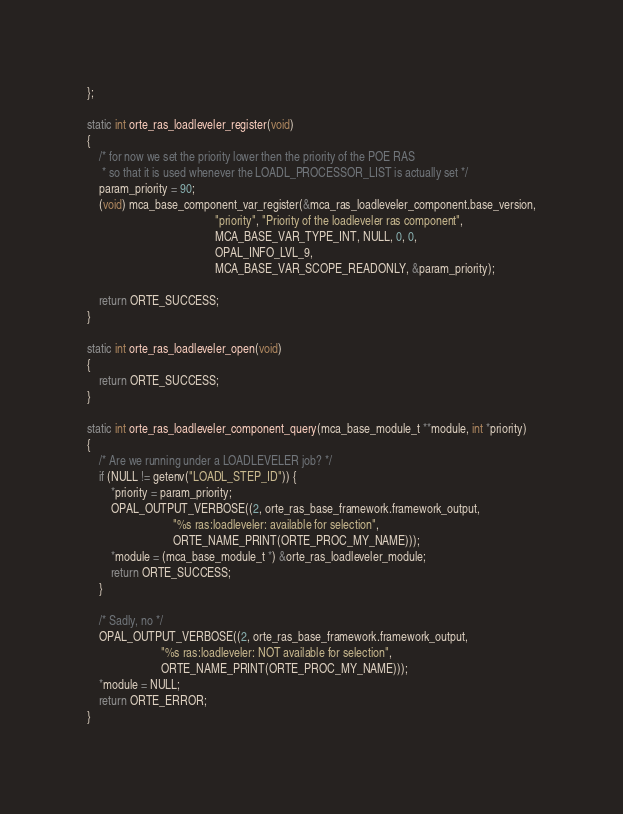Convert code to text. <code><loc_0><loc_0><loc_500><loc_500><_C_>};

static int orte_ras_loadleveler_register(void)
{
    /* for now we set the priority lower then the priority of the POE RAS
     * so that it is used whenever the LOADL_PROCESSOR_LIST is actually set */
    param_priority = 90;
    (void) mca_base_component_var_register(&mca_ras_loadleveler_component.base_version,
                                           "priority", "Priority of the loadleveler ras component",
                                           MCA_BASE_VAR_TYPE_INT, NULL, 0, 0,
                                           OPAL_INFO_LVL_9,
                                           MCA_BASE_VAR_SCOPE_READONLY, &param_priority);

    return ORTE_SUCCESS;
}

static int orte_ras_loadleveler_open(void)
{
    return ORTE_SUCCESS;
}

static int orte_ras_loadleveler_component_query(mca_base_module_t **module, int *priority)
{
    /* Are we running under a LOADLEVELER job? */
    if (NULL != getenv("LOADL_STEP_ID")) {
        *priority = param_priority;
        OPAL_OUTPUT_VERBOSE((2, orte_ras_base_framework.framework_output,
                             "%s ras:loadleveler: available for selection",
                             ORTE_NAME_PRINT(ORTE_PROC_MY_NAME)));
        *module = (mca_base_module_t *) &orte_ras_loadleveler_module;
        return ORTE_SUCCESS;
    }

    /* Sadly, no */
    OPAL_OUTPUT_VERBOSE((2, orte_ras_base_framework.framework_output,
                         "%s ras:loadleveler: NOT available for selection",
                         ORTE_NAME_PRINT(ORTE_PROC_MY_NAME)));
    *module = NULL;
    return ORTE_ERROR;
}

</code> 